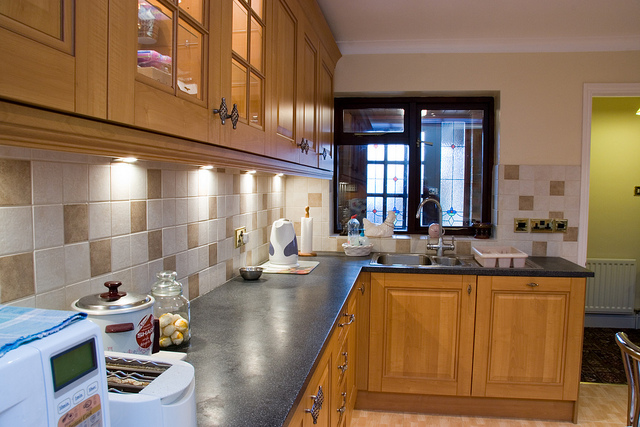What appliance is next to the microwave?
A. refrigerator
B. toaster
C. oven
D. dishwasher The device next to the microwave appears to be an oven, which is typically used for baking or roasting food. It often has a front door, multiple racks inside, and various control knobs or a digital panel, similar to what we can observe in the image. So, the correct answer is C. oven. 